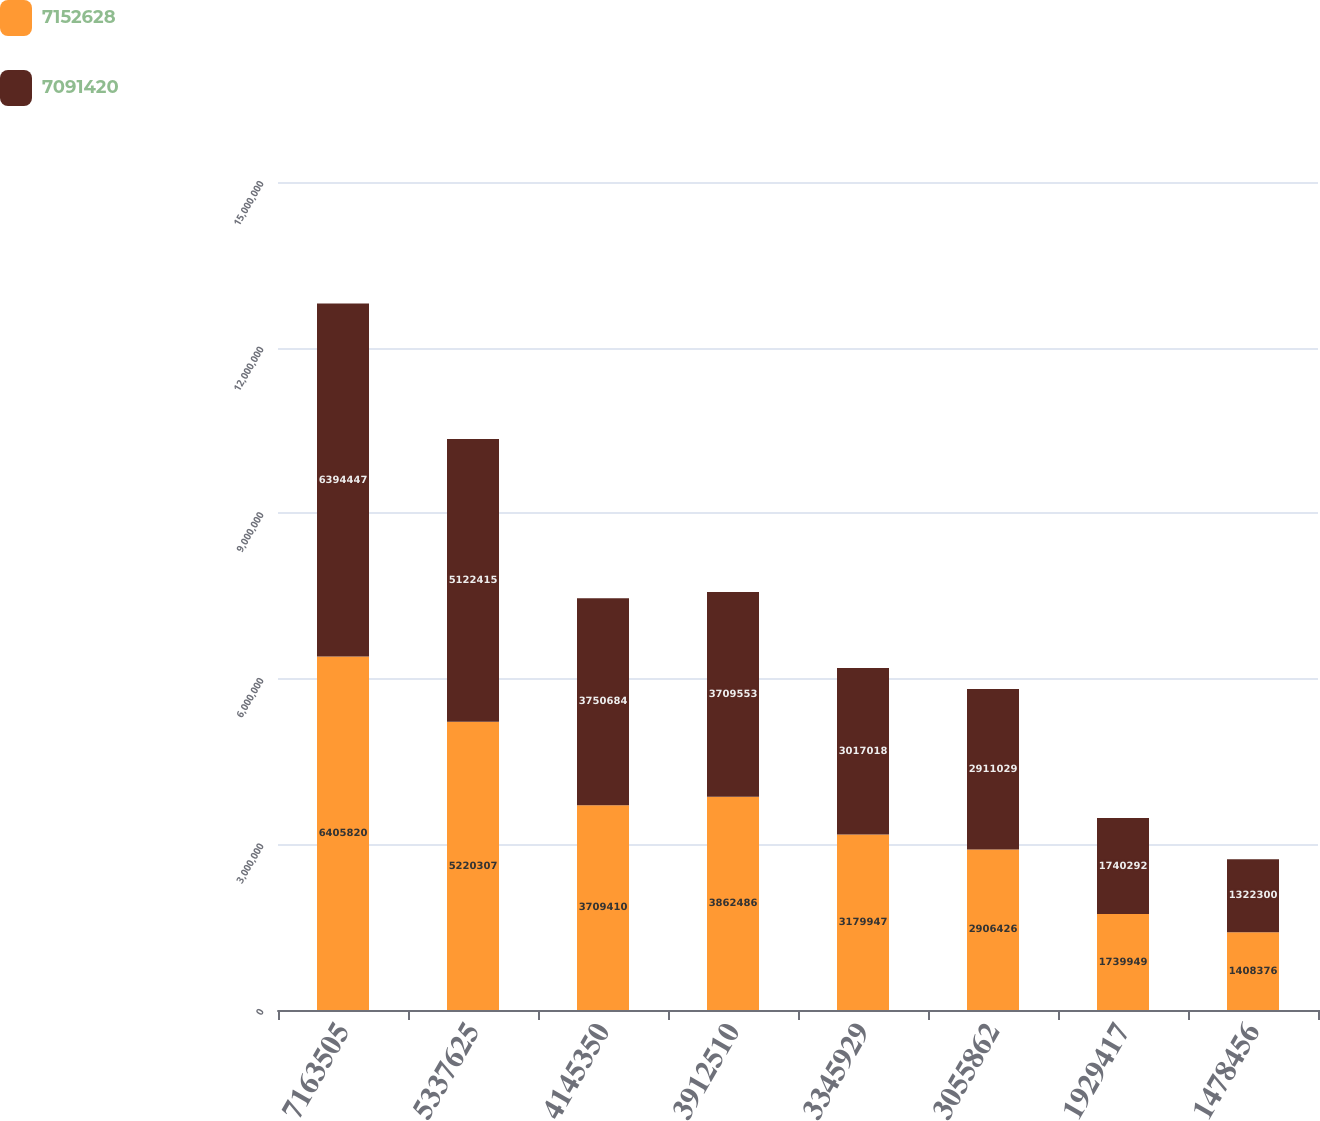Convert chart to OTSL. <chart><loc_0><loc_0><loc_500><loc_500><stacked_bar_chart><ecel><fcel>7163505<fcel>5337625<fcel>4145350<fcel>3912510<fcel>3345929<fcel>3055862<fcel>1929417<fcel>1478456<nl><fcel>7.15263e+06<fcel>6.40582e+06<fcel>5.22031e+06<fcel>3.70941e+06<fcel>3.86249e+06<fcel>3.17995e+06<fcel>2.90643e+06<fcel>1.73995e+06<fcel>1.40838e+06<nl><fcel>7.09142e+06<fcel>6.39445e+06<fcel>5.12242e+06<fcel>3.75068e+06<fcel>3.70955e+06<fcel>3.01702e+06<fcel>2.91103e+06<fcel>1.74029e+06<fcel>1.3223e+06<nl></chart> 